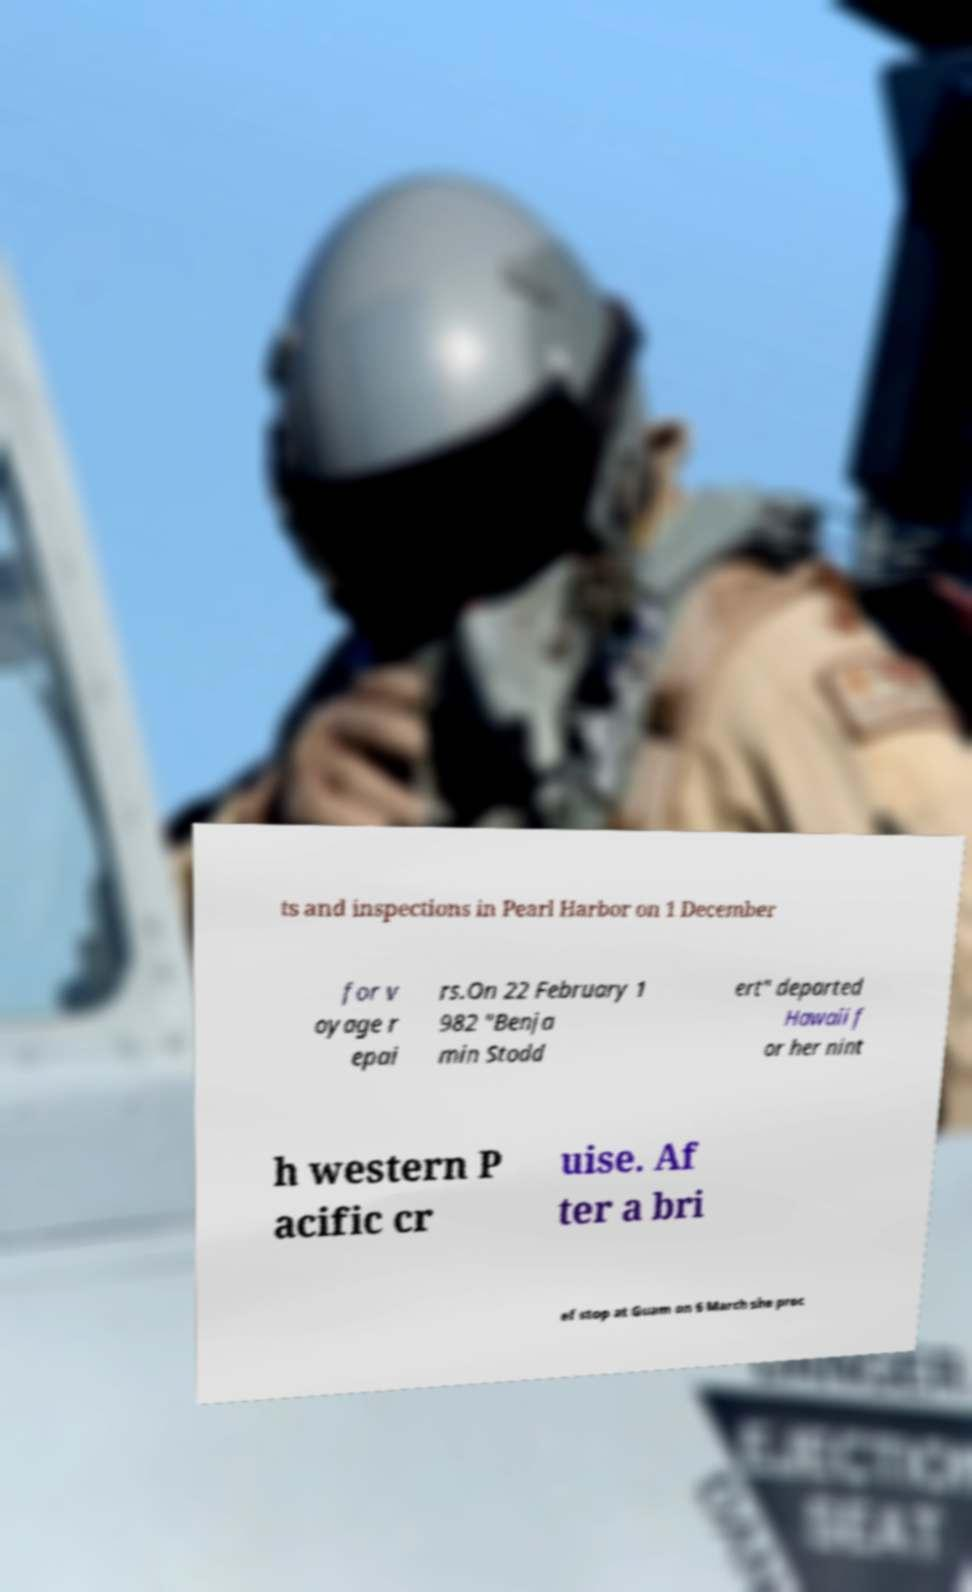What messages or text are displayed in this image? I need them in a readable, typed format. ts and inspections in Pearl Harbor on 1 December for v oyage r epai rs.On 22 February 1 982 "Benja min Stodd ert" departed Hawaii f or her nint h western P acific cr uise. Af ter a bri ef stop at Guam on 6 March she proc 